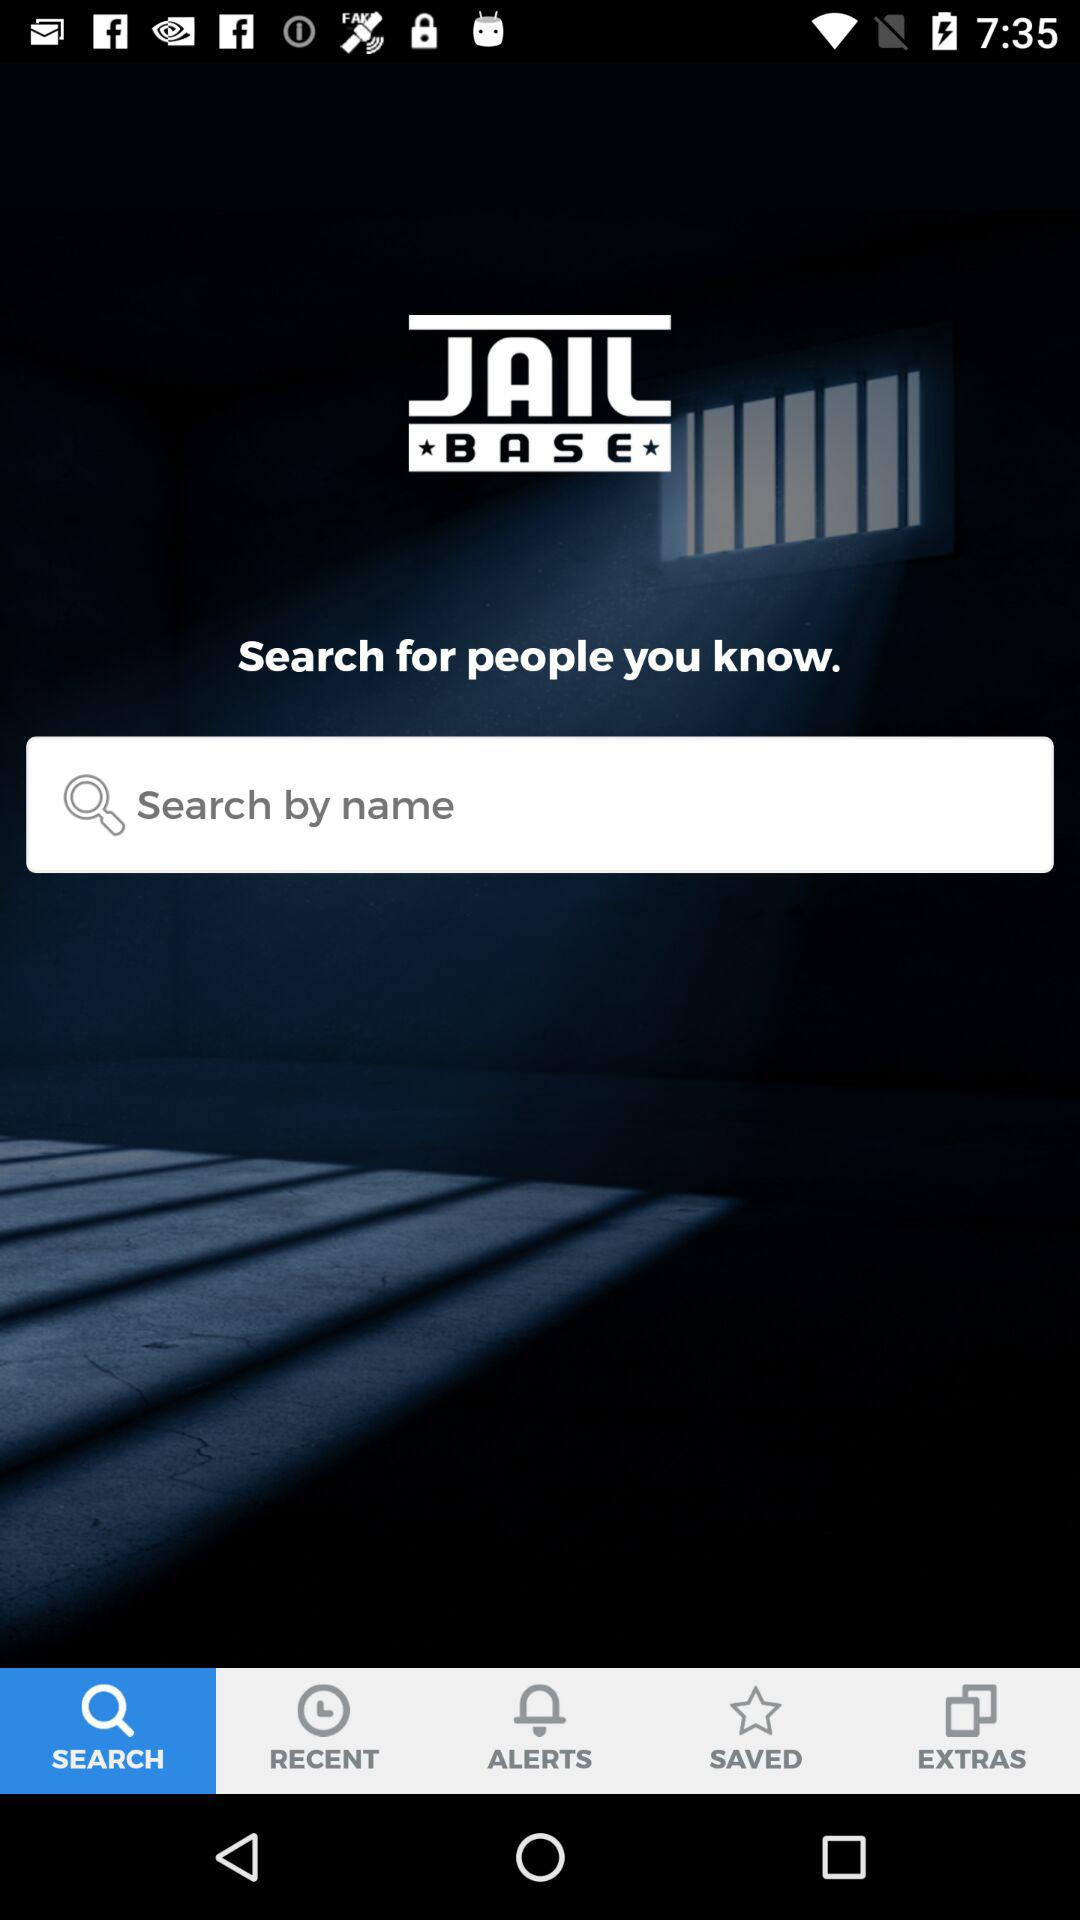Which tab is selected? The tab is "SEARCH". 